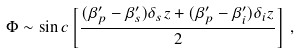<formula> <loc_0><loc_0><loc_500><loc_500>\Phi \sim \sin c \left [ \frac { ( \beta _ { p } ^ { \prime } - \beta _ { s } ^ { \prime } ) \delta _ { s } z + ( \beta _ { p } ^ { \prime } - \beta _ { i } ^ { \prime } ) \delta _ { i } z } { 2 } \right ] \, ,</formula> 